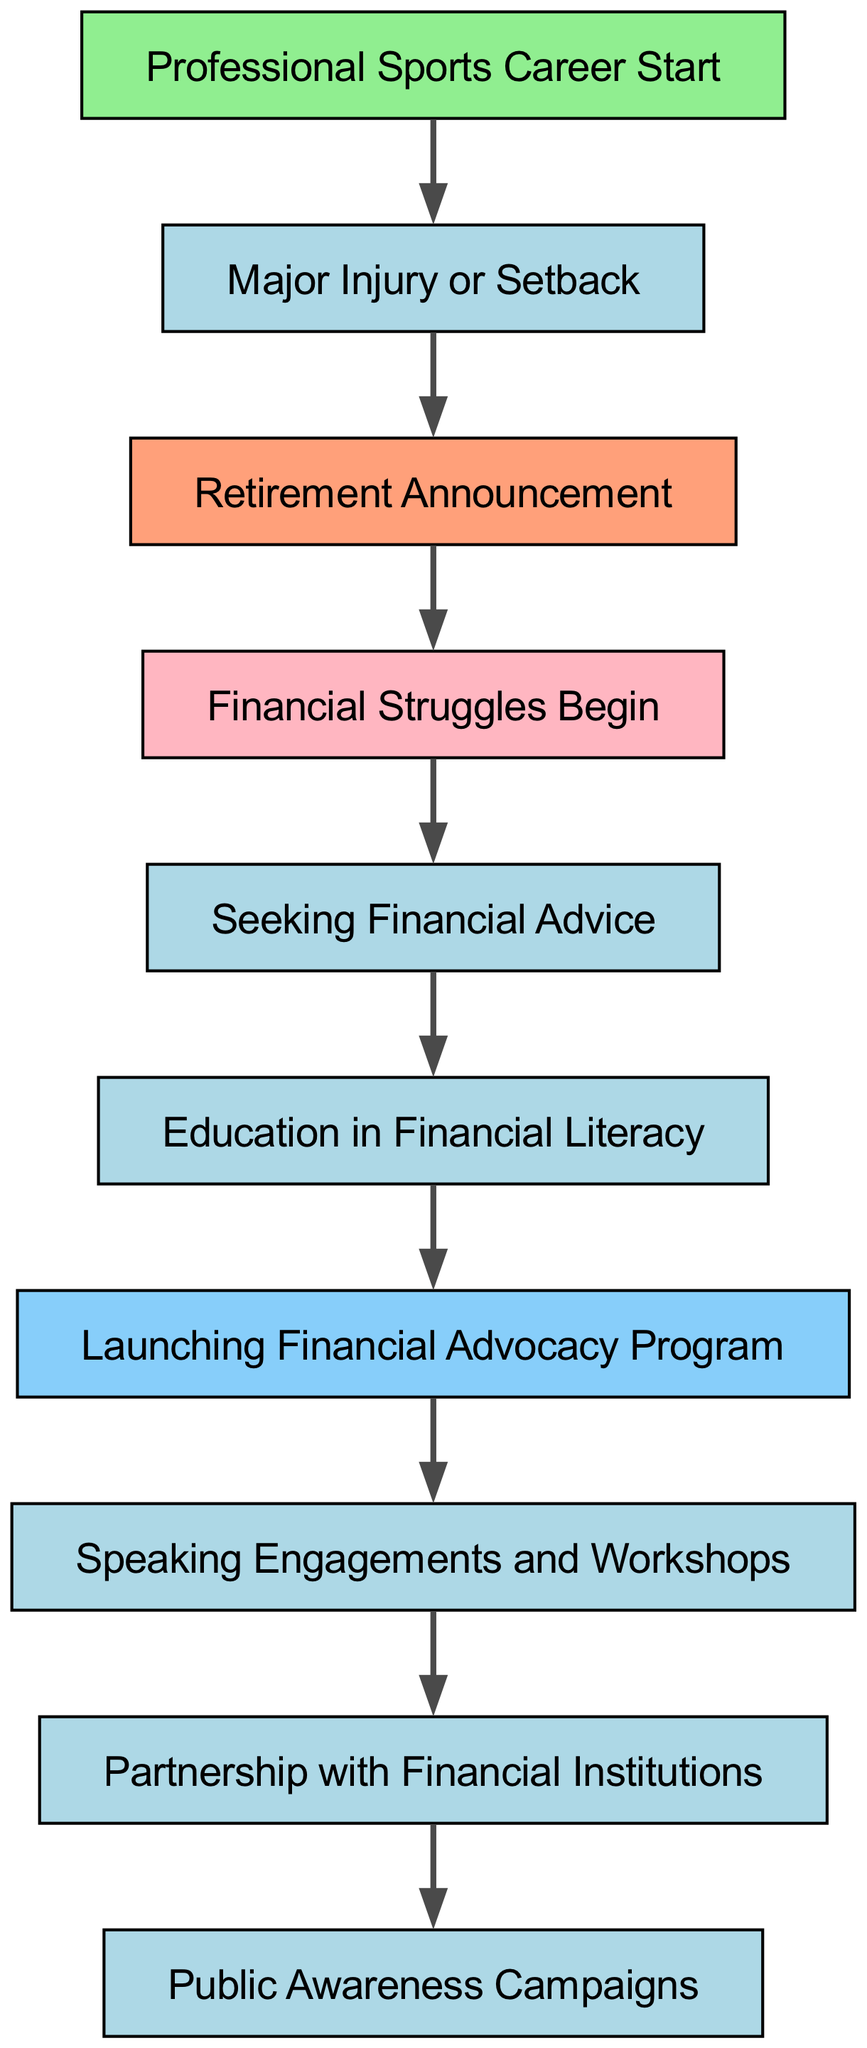What is the first milestone in the diagram? The diagram starts with the node labeled "Professional Sports Career Start," which is the first milestone listed.
Answer: Professional Sports Career Start How many nodes are there in the diagram? By counting the entries in the nodes list, there are a total of ten nodes represented in the diagram.
Answer: 10 What follows "Retirement Announcement" in the timeline? Looking at the direct connection from the "Retirement Announcement" node, it leads to the "Financial Struggles Begin" node, indicating the next event in the timeline.
Answer: Financial Struggles Begin Which node represents a decision made after experiencing financial struggles? The "Seeking Financial Advice" node follows directly after the "Financial Struggles Begin" node, denoting a decision made in response to those struggles.
Answer: Seeking Financial Advice What is the final node in the diagram? The last node, which is the endpoint of the directed flow, is labeled "Public Awareness Campaigns," indicating it is the conclusion of the advocacy journey shown in the diagram.
Answer: Public Awareness Campaigns Which milestone comes after "Education in Financial Literacy"? Following the "Education in Financial Literacy" node, the diagram shows an arrow directing to the "Launching Financial Advocacy Program" node, indicating the next step in the timeline.
Answer: Launching Financial Advocacy Program What kind of campaigns are depicted at the end of the timeline? The final node indicates that "Public Awareness Campaigns" are represented, showcasing outreach efforts following the advocacy program.
Answer: Public Awareness Campaigns Which node describes the initial stage where financial well-being issues arise? The node labeled "Financial Struggles Begin" specifically indicates the initial point at which financial well-being problems manifest after retirement.
Answer: Financial Struggles Begin How many edges are present in the diagram? By counting the relationships connecting the nodes, there are a total of nine edges represented in the diagram.
Answer: 9 